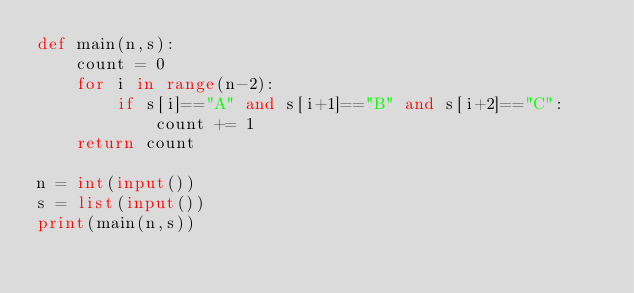<code> <loc_0><loc_0><loc_500><loc_500><_Python_>def main(n,s):
    count = 0
    for i in range(n-2):
        if s[i]=="A" and s[i+1]=="B" and s[i+2]=="C":
            count += 1
    return count

n = int(input())
s = list(input())
print(main(n,s))</code> 